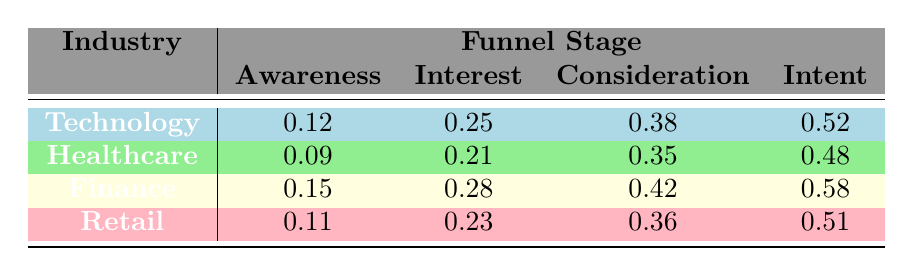What is the highest conversion rate in the Technology industry? In the Technology industry, the funnel stages are Awareness (0.12), Interest (0.25), Consideration (0.38), and Intent (0.52). The highest conversion rate is at the Intent stage.
Answer: 0.52 Which industry has the lowest conversion rate at the Awareness stage? At the Awareness stage, the conversion rates are Technology (0.12), Healthcare (0.09), Finance (0.15), and Retail (0.11). Healthcare has the lowest conversion rate at this stage.
Answer: Healthcare What is the average conversion rate for the Intent stage across all industries? The conversion rates for the Intent stage are Technology (0.52), Healthcare (0.48), Finance (0.58), and Retail (0.51). To find the average, sum the values: 0.52 + 0.48 + 0.58 + 0.51 = 2.09. Then divide by the number of industries (4): 2.09 / 4 = 0.5225.
Answer: 0.52 Is the conversion rate for the Interest stage in Finance higher than in Retail? The conversion rate for the Interest stage in Finance is 0.28 and in Retail, it is 0.23. Since 0.28 is greater than 0.23, the statement is true.
Answer: Yes What is the total conversion rate for the Consideration stage across Technology and Finance? The conversion rates for the Consideration stage are Technology (0.38) and Finance (0.42). To find the total, add the two rates: 0.38 + 0.42 = 0.80.
Answer: 0.80 What industry shows the greatest difference in conversion rates between the Intent and Awareness stages? For the Technology industry, the difference is 0.52 (Intent) - 0.12 (Awareness) = 0.40. For Healthcare, it is 0.48 - 0.09 = 0.39. For Finance, it is 0.58 - 0.15 = 0.43. For Retail, it is 0.51 - 0.11 = 0.40. The Finance industry has the greatest difference of 0.43.
Answer: Finance What is the conversion rate for Consideration in the Healthcare industry? The data shows that the conversion rate for the Consideration stage in the Healthcare industry is 0.35.
Answer: 0.35 Which industry has the highest conversion rate in the Interest stage? The conversion rates for the Interest stage are as follows: Technology (0.25), Healthcare (0.21), Finance (0.28), and Retail (0.23). The highest rate is for Finance at 0.28.
Answer: Finance 